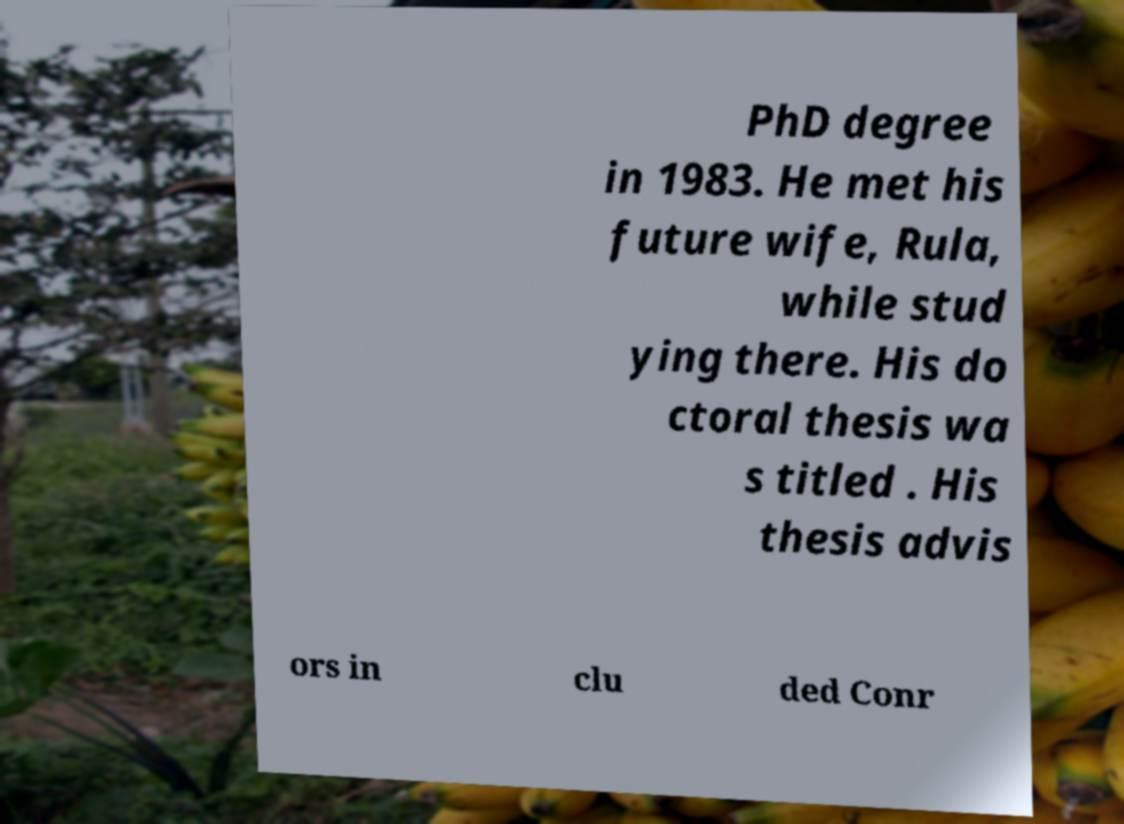Can you accurately transcribe the text from the provided image for me? PhD degree in 1983. He met his future wife, Rula, while stud ying there. His do ctoral thesis wa s titled . His thesis advis ors in clu ded Conr 